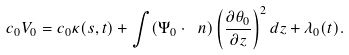<formula> <loc_0><loc_0><loc_500><loc_500>c _ { 0 } V _ { 0 } = c _ { 0 } \kappa ( s , t ) + \int ( \Psi _ { 0 } \cdot \ n ) \left ( \frac { \partial \theta _ { 0 } } { \partial z } \right ) ^ { 2 } d z + \lambda _ { 0 } ( t ) .</formula> 